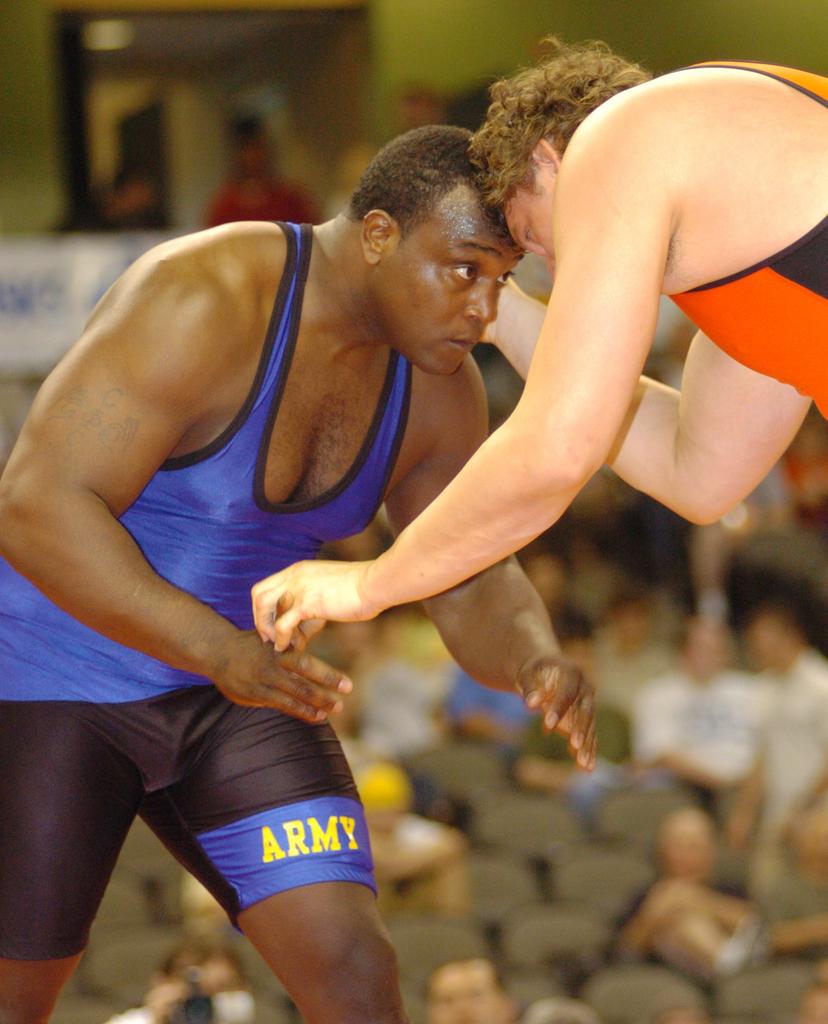What school does the wrestler on the left play for?
Offer a terse response. Army. 